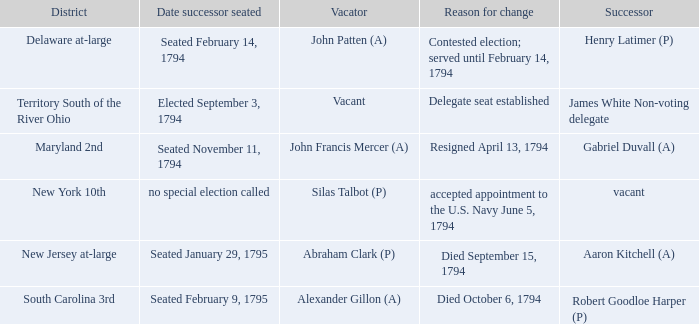Name the date successor seated for delegate seat established Elected September 3, 1794. Give me the full table as a dictionary. {'header': ['District', 'Date successor seated', 'Vacator', 'Reason for change', 'Successor'], 'rows': [['Delaware at-large', 'Seated February 14, 1794', 'John Patten (A)', 'Contested election; served until February 14, 1794', 'Henry Latimer (P)'], ['Territory South of the River Ohio', 'Elected September 3, 1794', 'Vacant', 'Delegate seat established', 'James White Non-voting delegate'], ['Maryland 2nd', 'Seated November 11, 1794', 'John Francis Mercer (A)', 'Resigned April 13, 1794', 'Gabriel Duvall (A)'], ['New York 10th', 'no special election called', 'Silas Talbot (P)', 'accepted appointment to the U.S. Navy June 5, 1794', 'vacant'], ['New Jersey at-large', 'Seated January 29, 1795', 'Abraham Clark (P)', 'Died September 15, 1794', 'Aaron Kitchell (A)'], ['South Carolina 3rd', 'Seated February 9, 1795', 'Alexander Gillon (A)', 'Died October 6, 1794', 'Robert Goodloe Harper (P)']]} 